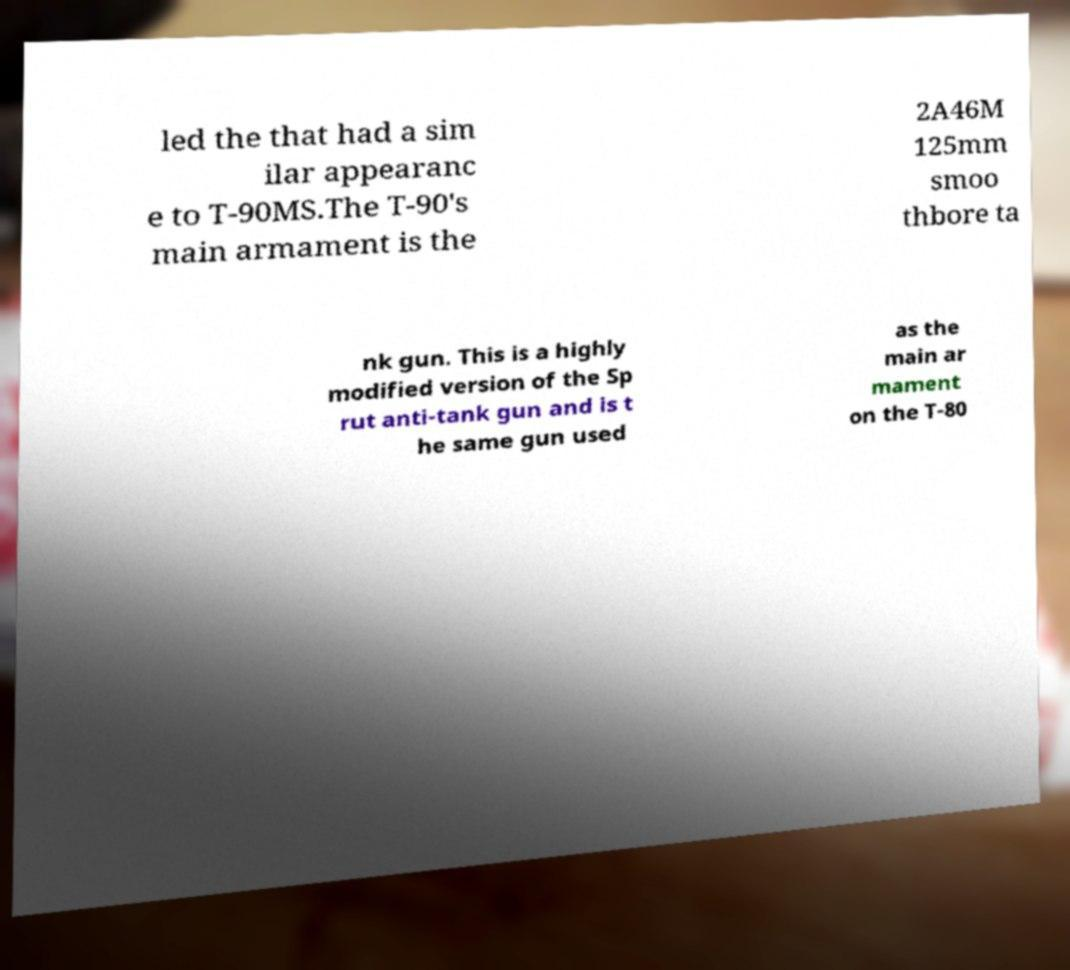Can you accurately transcribe the text from the provided image for me? led the that had a sim ilar appearanc e to T-90MS.The T-90's main armament is the 2A46M 125mm smoo thbore ta nk gun. This is a highly modified version of the Sp rut anti-tank gun and is t he same gun used as the main ar mament on the T-80 